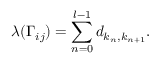Convert formula to latex. <formula><loc_0><loc_0><loc_500><loc_500>\lambda ( \Gamma _ { i j } ) = \sum _ { n = 0 } ^ { l - 1 } d _ { k _ { n } , k _ { n + 1 } } .</formula> 